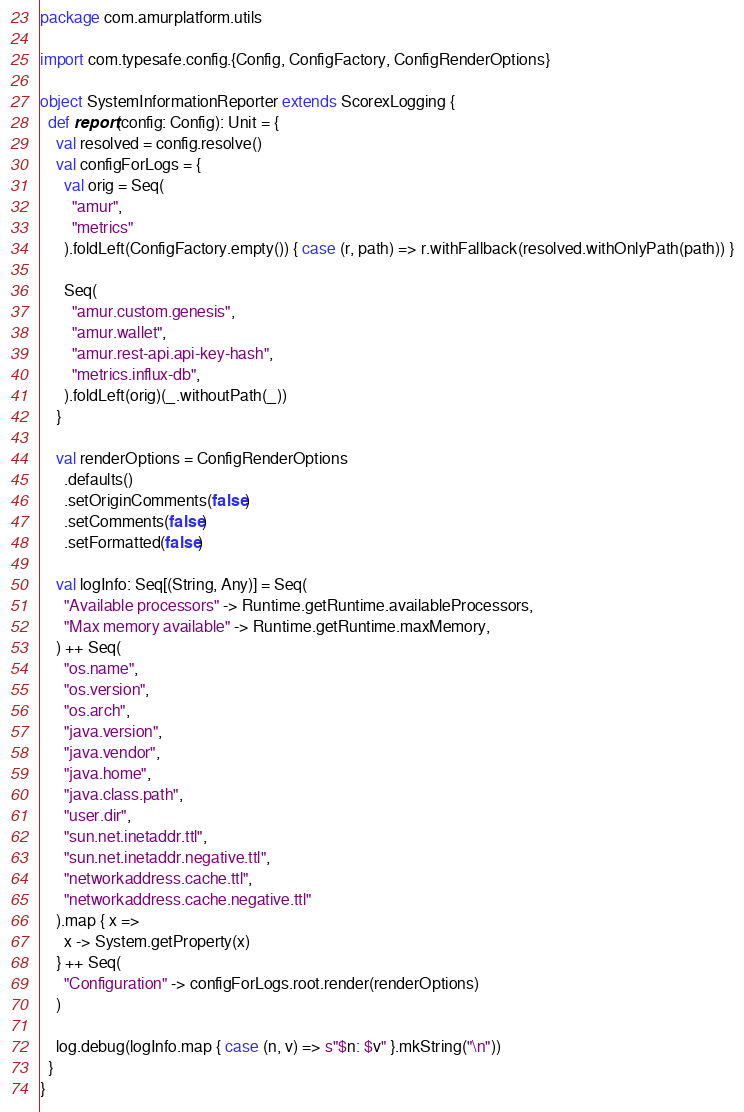<code> <loc_0><loc_0><loc_500><loc_500><_Scala_>package com.amurplatform.utils

import com.typesafe.config.{Config, ConfigFactory, ConfigRenderOptions}

object SystemInformationReporter extends ScorexLogging {
  def report(config: Config): Unit = {
    val resolved = config.resolve()
    val configForLogs = {
      val orig = Seq(
        "amur",
        "metrics"
      ).foldLeft(ConfigFactory.empty()) { case (r, path) => r.withFallback(resolved.withOnlyPath(path)) }

      Seq(
        "amur.custom.genesis",
        "amur.wallet",
        "amur.rest-api.api-key-hash",
        "metrics.influx-db",
      ).foldLeft(orig)(_.withoutPath(_))
    }

    val renderOptions = ConfigRenderOptions
      .defaults()
      .setOriginComments(false)
      .setComments(false)
      .setFormatted(false)

    val logInfo: Seq[(String, Any)] = Seq(
      "Available processors" -> Runtime.getRuntime.availableProcessors,
      "Max memory available" -> Runtime.getRuntime.maxMemory,
    ) ++ Seq(
      "os.name",
      "os.version",
      "os.arch",
      "java.version",
      "java.vendor",
      "java.home",
      "java.class.path",
      "user.dir",
      "sun.net.inetaddr.ttl",
      "sun.net.inetaddr.negative.ttl",
      "networkaddress.cache.ttl",
      "networkaddress.cache.negative.ttl"
    ).map { x =>
      x -> System.getProperty(x)
    } ++ Seq(
      "Configuration" -> configForLogs.root.render(renderOptions)
    )

    log.debug(logInfo.map { case (n, v) => s"$n: $v" }.mkString("\n"))
  }
}
</code> 